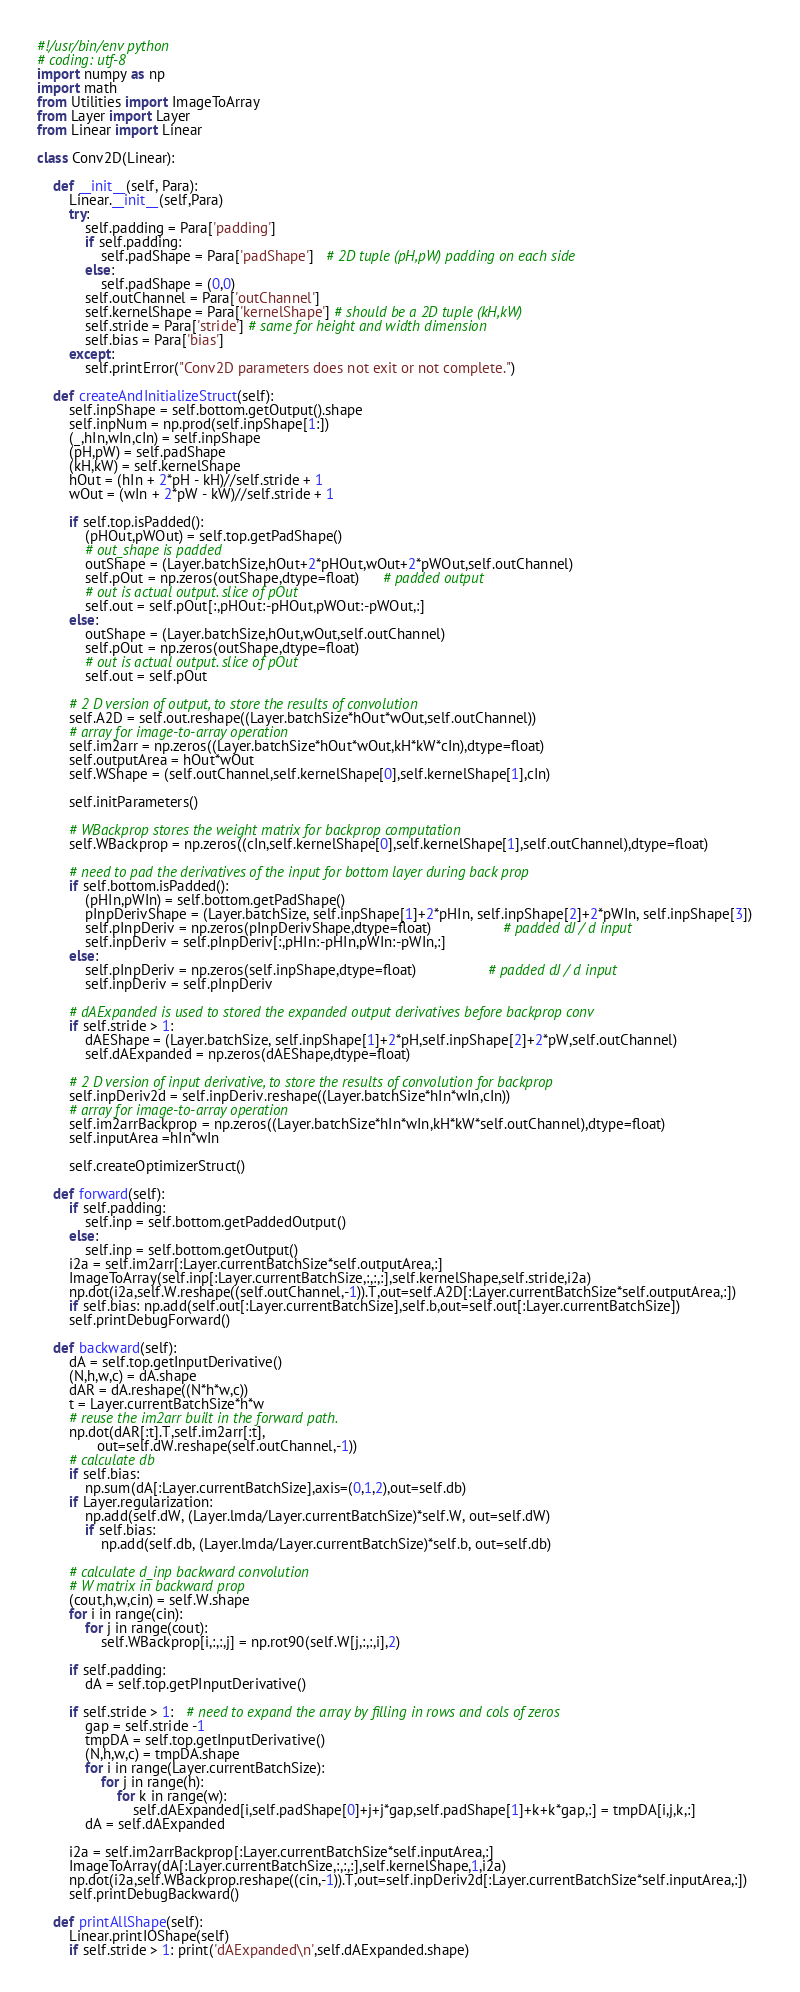<code> <loc_0><loc_0><loc_500><loc_500><_Python_>#!/usr/bin/env python
# coding: utf-8
import numpy as np
import math
from Utilities import ImageToArray
from Layer import Layer
from Linear import Linear

class Conv2D(Linear):
        
    def __init__(self, Para):
        Linear.__init__(self,Para)
        try:
            self.padding = Para['padding']
            if self.padding:
                self.padShape = Para['padShape']   # 2D tuple (pH,pW) padding on each side
            else:
                self.padShape = (0,0)
            self.outChannel = Para['outChannel']
            self.kernelShape = Para['kernelShape'] # should be a 2D tuple (kH,kW)
            self.stride = Para['stride'] # same for height and width dimension
            self.bias = Para['bias']
        except:
            self.printError("Conv2D parameters does not exit or not complete.")
    
    def createAndInitializeStruct(self):
        self.inpShape = self.bottom.getOutput().shape
        self.inpNum = np.prod(self.inpShape[1:])
        (_,hIn,wIn,cIn) = self.inpShape
        (pH,pW) = self.padShape
        (kH,kW) = self.kernelShape
        hOut = (hIn + 2*pH - kH)//self.stride + 1
        wOut = (wIn + 2*pW - kW)//self.stride + 1
        
        if self.top.isPadded():
            (pHOut,pWOut) = self.top.getPadShape()
            # out_shape is padded
            outShape = (Layer.batchSize,hOut+2*pHOut,wOut+2*pWOut,self.outChannel)
            self.pOut = np.zeros(outShape,dtype=float)      # padded output
            # out is actual output. slice of pOut
            self.out = self.pOut[:,pHOut:-pHOut,pWOut:-pWOut,:]
        else:
            outShape = (Layer.batchSize,hOut,wOut,self.outChannel)
            self.pOut = np.zeros(outShape,dtype=float)      
            # out is actual output. slice of pOut
            self.out = self.pOut
        
        # 2 D version of output, to store the results of convolution
        self.A2D = self.out.reshape((Layer.batchSize*hOut*wOut,self.outChannel))
        # array for image-to-array operation
        self.im2arr = np.zeros((Layer.batchSize*hOut*wOut,kH*kW*cIn),dtype=float)
        self.outputArea = hOut*wOut        
        self.WShape = (self.outChannel,self.kernelShape[0],self.kernelShape[1],cIn)
        
        self.initParameters()
                
        # WBackprop stores the weight matrix for backprop computation
        self.WBackprop = np.zeros((cIn,self.kernelShape[0],self.kernelShape[1],self.outChannel),dtype=float)
        
        # need to pad the derivatives of the input for bottom layer during back prop
        if self.bottom.isPadded():
            (pHIn,pWIn) = self.bottom.getPadShape()
            pInpDerivShape = (Layer.batchSize, self.inpShape[1]+2*pHIn, self.inpShape[2]+2*pWIn, self.inpShape[3])
            self.pInpDeriv = np.zeros(pInpDerivShape,dtype=float)                  # padded dJ / d input
            self.inpDeriv = self.pInpDeriv[:,pHIn:-pHIn,pWIn:-pWIn,:]
        else:
            self.pInpDeriv = np.zeros(self.inpShape,dtype=float)                  # padded dJ / d input
            self.inpDeriv = self.pInpDeriv
            
        # dAExpanded is used to stored the expanded output derivatives before backprop conv
        if self.stride > 1:
            dAEShape = (Layer.batchSize, self.inpShape[1]+2*pH,self.inpShape[2]+2*pW,self.outChannel)
            self.dAExpanded = np.zeros(dAEShape,dtype=float)
                
        # 2 D version of input derivative, to store the results of convolution for backprop
        self.inpDeriv2d = self.inpDeriv.reshape((Layer.batchSize*hIn*wIn,cIn))
        # array for image-to-array operation
        self.im2arrBackprop = np.zeros((Layer.batchSize*hIn*wIn,kH*kW*self.outChannel),dtype=float)
        self.inputArea =hIn*wIn
        
        self.createOptimizerStruct()
        
    def forward(self):
        if self.padding:
            self.inp = self.bottom.getPaddedOutput()
        else:
            self.inp = self.bottom.getOutput()
        i2a = self.im2arr[:Layer.currentBatchSize*self.outputArea,:]
        ImageToArray(self.inp[:Layer.currentBatchSize,:,:,:],self.kernelShape,self.stride,i2a)
        np.dot(i2a,self.W.reshape((self.outChannel,-1)).T,out=self.A2D[:Layer.currentBatchSize*self.outputArea,:])
        if self.bias: np.add(self.out[:Layer.currentBatchSize],self.b,out=self.out[:Layer.currentBatchSize])    
        self.printDebugForward()
    
    def backward(self):
        dA = self.top.getInputDerivative()
        (N,h,w,c) = dA.shape
        dAR = dA.reshape((N*h*w,c))
        t = Layer.currentBatchSize*h*w
        # reuse the im2arr built in the forward path. 
        np.dot(dAR[:t].T,self.im2arr[:t], 
               out=self.dW.reshape(self.outChannel,-1))
        # calculate db
        if self.bias: 
            np.sum(dA[:Layer.currentBatchSize],axis=(0,1,2),out=self.db)
        if Layer.regularization:
            np.add(self.dW, (Layer.lmda/Layer.currentBatchSize)*self.W, out=self.dW)
            if self.bias:
                np.add(self.db, (Layer.lmda/Layer.currentBatchSize)*self.b, out=self.db)
            
        # calculate d_inp backward convolution
        # W matrix in backward prop
        (cout,h,w,cin) = self.W.shape
        for i in range(cin):
            for j in range(cout):
                self.WBackprop[i,:,:,j] = np.rot90(self.W[j,:,:,i],2)

        if self.padding: 
            dA = self.top.getPInputDerivative()

        if self.stride > 1:   # need to expand the array by filling in rows and cols of zeros
            gap = self.stride -1
            tmpDA = self.top.getInputDerivative()
            (N,h,w,c) = tmpDA.shape
            for i in range(Layer.currentBatchSize):
                for j in range(h):
                    for k in range(w):
                        self.dAExpanded[i,self.padShape[0]+j+j*gap,self.padShape[1]+k+k*gap,:] = tmpDA[i,j,k,:]
            dA = self.dAExpanded
            
        i2a = self.im2arrBackprop[:Layer.currentBatchSize*self.inputArea,:]
        ImageToArray(dA[:Layer.currentBatchSize,:,:,:],self.kernelShape,1,i2a)
        np.dot(i2a,self.WBackprop.reshape((cin,-1)).T,out=self.inpDeriv2d[:Layer.currentBatchSize*self.inputArea,:])    
        self.printDebugBackward()

    def printAllShape(self):
        Linear.printIOShape(self)
        if self.stride > 1: print('dAExpanded\n',self.dAExpanded.shape)

</code> 